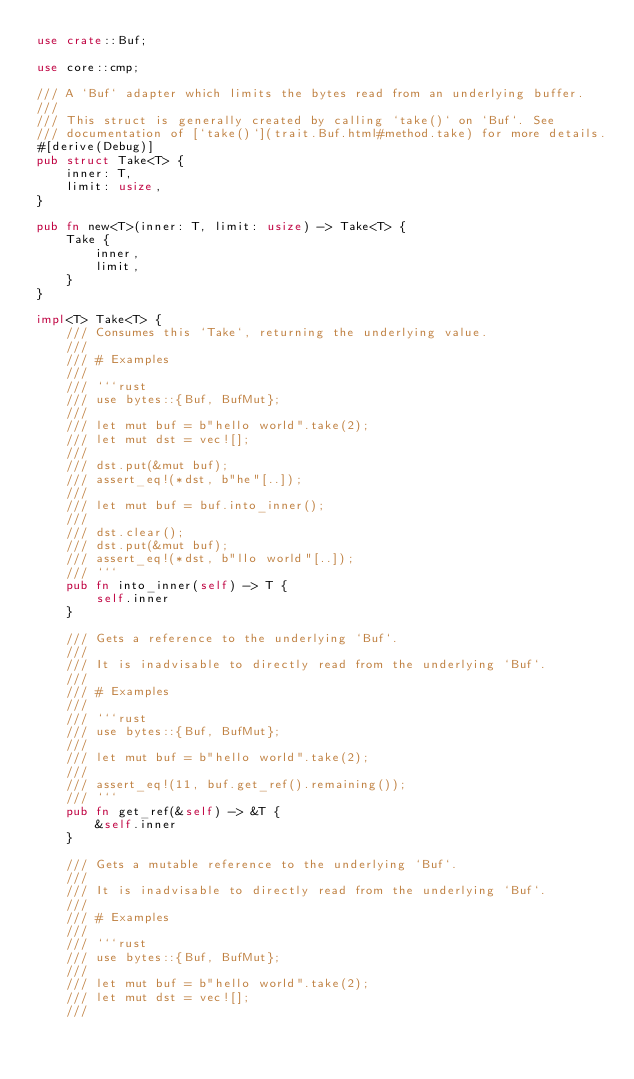<code> <loc_0><loc_0><loc_500><loc_500><_Rust_>use crate::Buf;

use core::cmp;

/// A `Buf` adapter which limits the bytes read from an underlying buffer.
///
/// This struct is generally created by calling `take()` on `Buf`. See
/// documentation of [`take()`](trait.Buf.html#method.take) for more details.
#[derive(Debug)]
pub struct Take<T> {
    inner: T,
    limit: usize,
}

pub fn new<T>(inner: T, limit: usize) -> Take<T> {
    Take {
        inner,
        limit,
    }
}

impl<T> Take<T> {
    /// Consumes this `Take`, returning the underlying value.
    ///
    /// # Examples
    ///
    /// ```rust
    /// use bytes::{Buf, BufMut};
    ///
    /// let mut buf = b"hello world".take(2);
    /// let mut dst = vec![];
    ///
    /// dst.put(&mut buf);
    /// assert_eq!(*dst, b"he"[..]);
    ///
    /// let mut buf = buf.into_inner();
    ///
    /// dst.clear();
    /// dst.put(&mut buf);
    /// assert_eq!(*dst, b"llo world"[..]);
    /// ```
    pub fn into_inner(self) -> T {
        self.inner
    }

    /// Gets a reference to the underlying `Buf`.
    ///
    /// It is inadvisable to directly read from the underlying `Buf`.
    ///
    /// # Examples
    ///
    /// ```rust
    /// use bytes::{Buf, BufMut};
    ///
    /// let mut buf = b"hello world".take(2);
    ///
    /// assert_eq!(11, buf.get_ref().remaining());
    /// ```
    pub fn get_ref(&self) -> &T {
        &self.inner
    }

    /// Gets a mutable reference to the underlying `Buf`.
    ///
    /// It is inadvisable to directly read from the underlying `Buf`.
    ///
    /// # Examples
    ///
    /// ```rust
    /// use bytes::{Buf, BufMut};
    ///
    /// let mut buf = b"hello world".take(2);
    /// let mut dst = vec![];
    ///</code> 